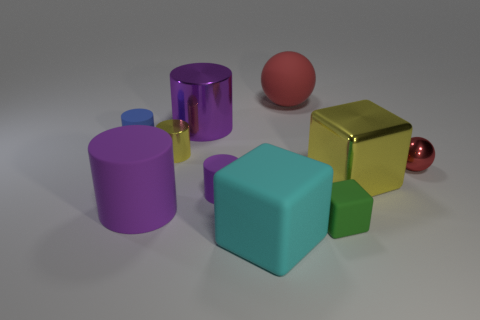There is a yellow object left of the yellow metallic thing that is on the right side of the tiny yellow cylinder; what is its shape?
Offer a very short reply. Cylinder. There is a metal cylinder that is the same color as the big metal block; what is its size?
Your answer should be compact. Small. Is there a gray ball that has the same material as the small green thing?
Make the answer very short. No. There is a red thing left of the red shiny ball; what is its material?
Provide a short and direct response. Rubber. What is the tiny red thing made of?
Provide a succinct answer. Metal. Does the yellow object in front of the red metallic sphere have the same material as the small purple cylinder?
Your answer should be compact. No. Are there fewer red rubber balls that are left of the small green block than metal blocks?
Offer a very short reply. No. What color is the block that is the same size as the blue cylinder?
Your answer should be very brief. Green. How many large cyan things have the same shape as the tiny green matte thing?
Provide a succinct answer. 1. What color is the small matte object on the right side of the large red rubber ball?
Your answer should be compact. Green. 